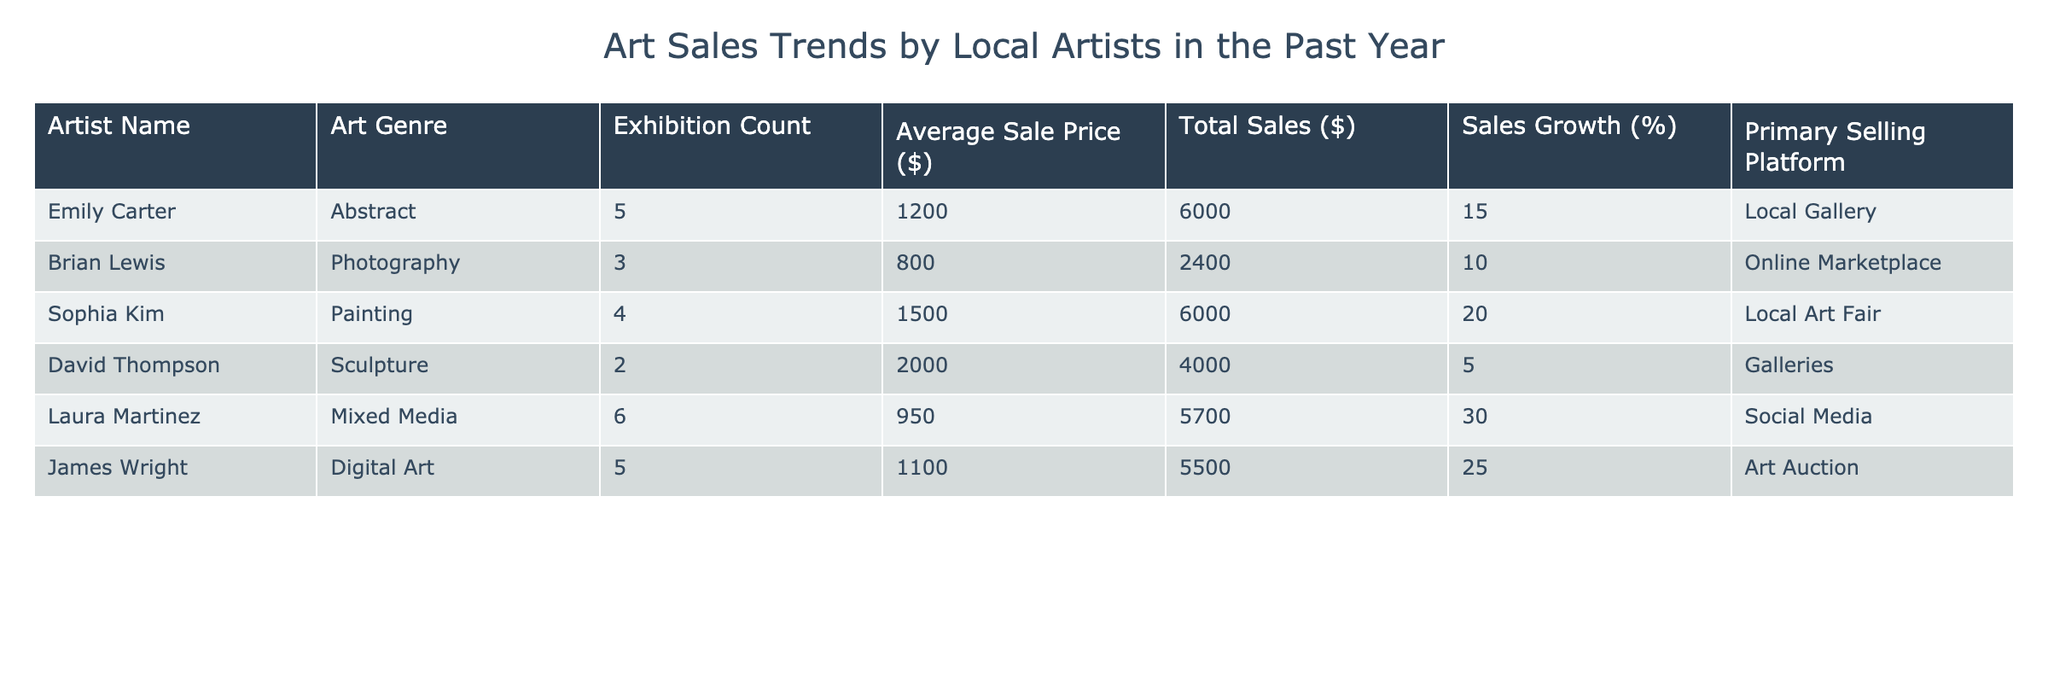What is the total sales amount for Emily Carter? The total sales for Emily Carter is listed in the table under the "Total Sales ($)" column, which shows as 6000.
Answer: 6000 Who had the highest average sale price? By comparing the "Average Sale Price ($)" column, David Thompson has the highest average sale price at 2000.
Answer: David Thompson What is the average sales growth percentage of all artists? To calculate the average sales growth percentage, sum all sales growth percentages (15 + 10 + 20 + 5 + 30 + 25 = 105) and divide by the number of artists (6): 105 / 6 = 17.5.
Answer: 17.5 Did Laura Martinez have a higher total sales amount than James Wright? Comparing the "Total Sales ($)" amounts, Laura Martinez had 5700 while James Wright had 5500. Since 5700 is greater than 5500, the answer is yes.
Answer: Yes Which artist sold the least number of artworks? The number of artworks sold can be inferred from the "Exhibition Count." David Thompson had 2 exhibitions, which is the least compared to other artists.
Answer: David Thompson What is the difference in total sales between the highest and lowest selling artists? The highest total sales is for Emily Carter at 6000 and the lowest is for Brian Lewis at 2400. The difference is calculated by subtracting the lowest from the highest: 6000 - 2400 = 3600.
Answer: 3600 How many artists sold their work using social media? In the "Primary Selling Platform" column, only Laura Martinez is listed under social media, which means there is 1 artist.
Answer: 1 Is it true that all artists have shown their work in at least 2 exhibitions? Checking the "Exhibition Count" column, David Thompson has only 2 exhibitions and Brian Lewis has 3. Since both meet the criteria, the answer is yes.
Answer: Yes Which genre of art had the most exhibitions in total? To find out which genre had the most exhibitions, sum the "Exhibition Count" for all genres: Abstract (5) + Photography (3) + Painting (4) + Sculpture (2) + Mixed Media (6) + Digital Art (5) = 25. Mixed Media had 6 exhibitions, the highest among them.
Answer: Mixed Media 